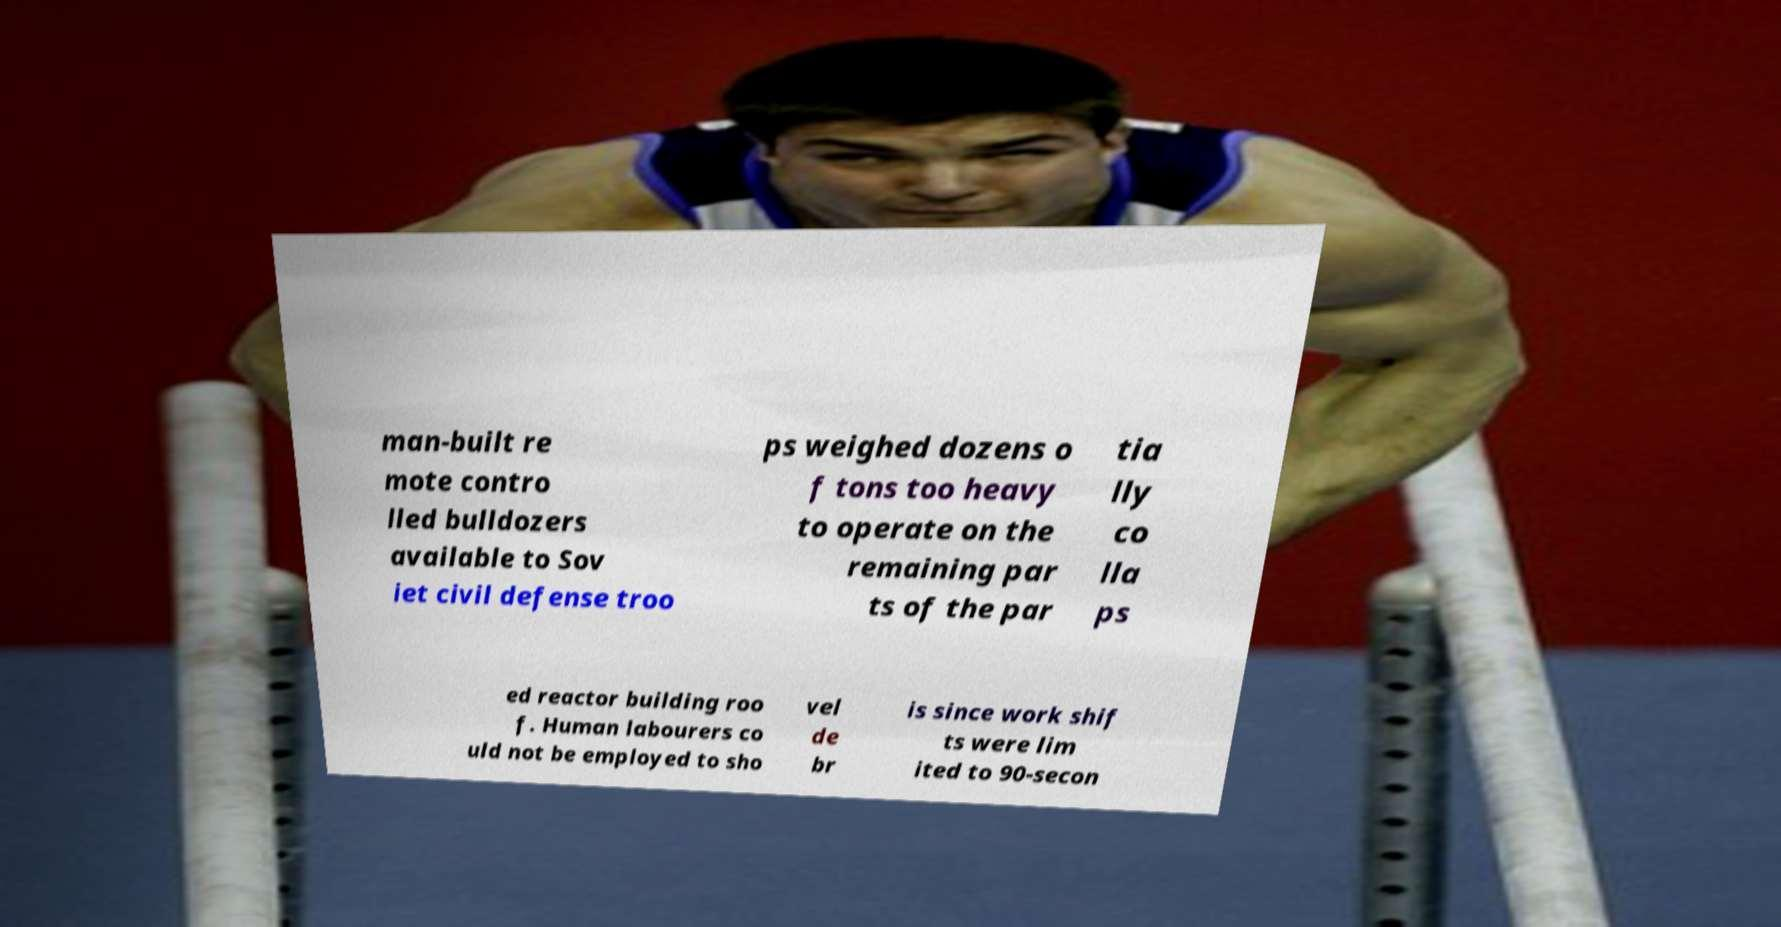There's text embedded in this image that I need extracted. Can you transcribe it verbatim? man-built re mote contro lled bulldozers available to Sov iet civil defense troo ps weighed dozens o f tons too heavy to operate on the remaining par ts of the par tia lly co lla ps ed reactor building roo f. Human labourers co uld not be employed to sho vel de br is since work shif ts were lim ited to 90-secon 